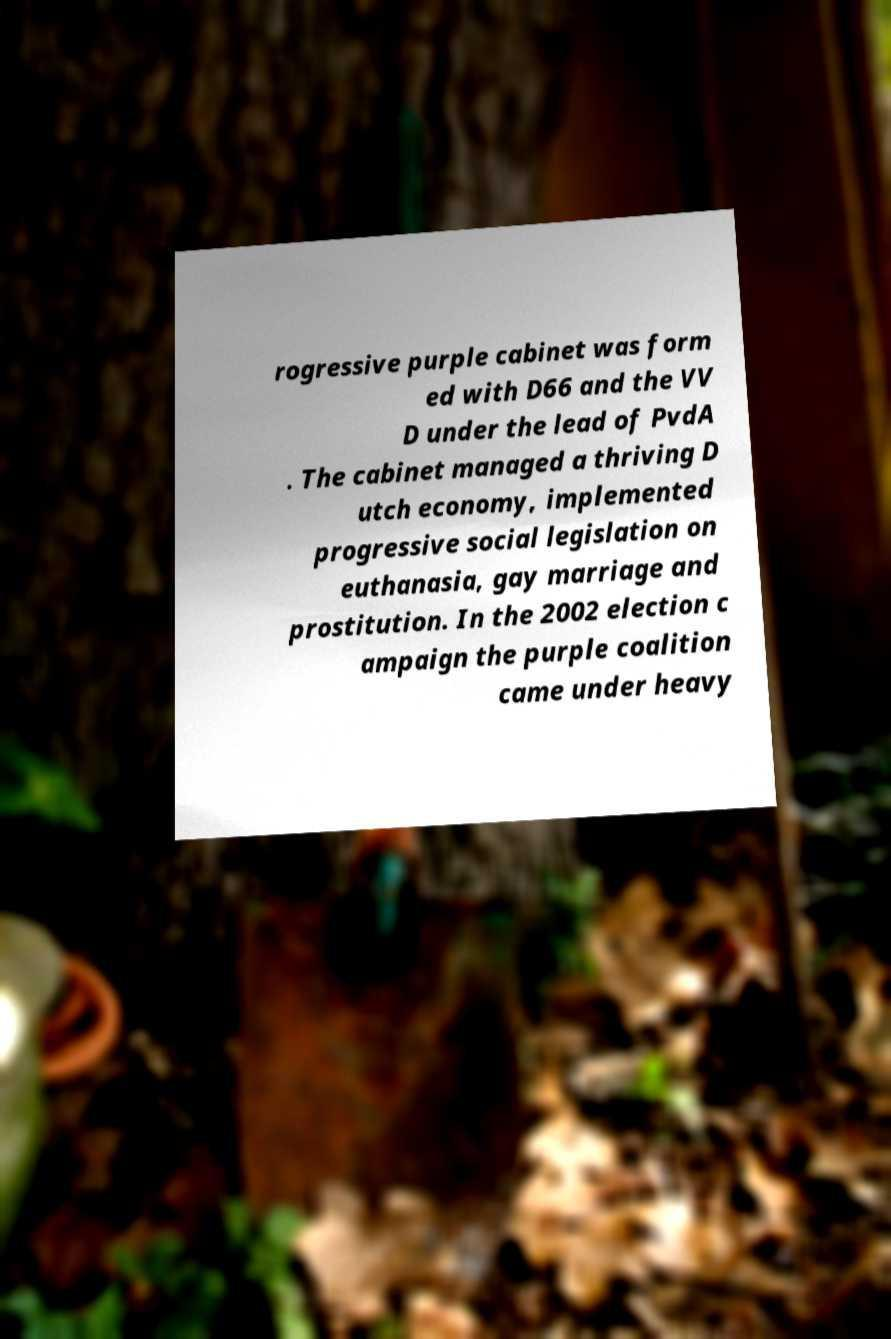Could you extract and type out the text from this image? rogressive purple cabinet was form ed with D66 and the VV D under the lead of PvdA . The cabinet managed a thriving D utch economy, implemented progressive social legislation on euthanasia, gay marriage and prostitution. In the 2002 election c ampaign the purple coalition came under heavy 